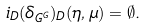Convert formula to latex. <formula><loc_0><loc_0><loc_500><loc_500>i _ { D } ( \delta _ { G ^ { G } } ) _ { D } ( \eta , \mu ) = \emptyset .</formula> 